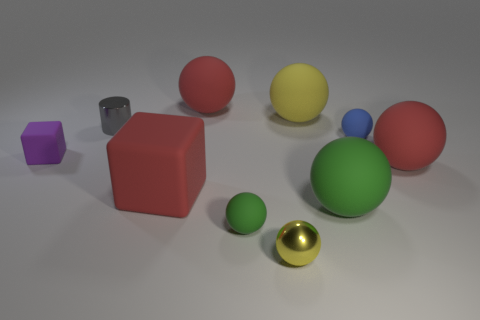Subtract 3 spheres. How many spheres are left? 4 Subtract all red balls. How many balls are left? 5 Subtract all small green rubber balls. How many balls are left? 6 Subtract all green spheres. Subtract all gray cylinders. How many spheres are left? 5 Subtract all blocks. How many objects are left? 8 Subtract all large green matte balls. Subtract all large green rubber spheres. How many objects are left? 8 Add 1 tiny yellow metallic objects. How many tiny yellow metallic objects are left? 2 Add 8 small blocks. How many small blocks exist? 9 Subtract 1 red blocks. How many objects are left? 9 